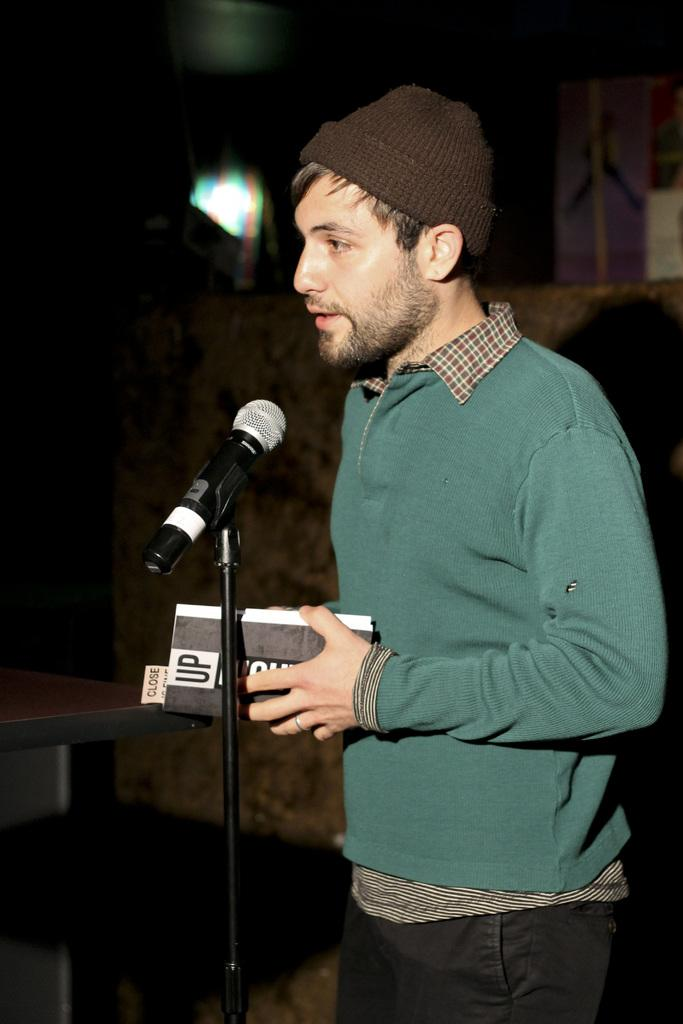Who is the main subject in the foreground of the image? There is a man in the foreground of the image. What is the man standing in front of? The man is standing in front of a mic stand. What is the man holding in his hand? The man is holding a book-like object. Can you describe the background of the image? The background of the image is not clear. How many rabbits can be seen in the image? There are no rabbits present in the image. What type of cattle is visible in the background of the image? There is no cattle visible in the image, as the background is not clear. 